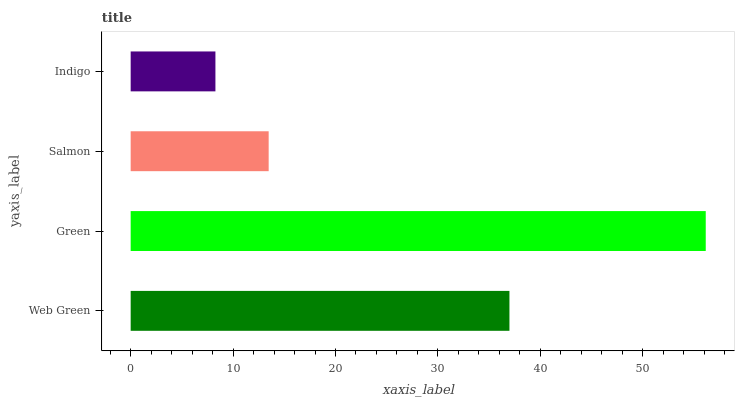Is Indigo the minimum?
Answer yes or no. Yes. Is Green the maximum?
Answer yes or no. Yes. Is Salmon the minimum?
Answer yes or no. No. Is Salmon the maximum?
Answer yes or no. No. Is Green greater than Salmon?
Answer yes or no. Yes. Is Salmon less than Green?
Answer yes or no. Yes. Is Salmon greater than Green?
Answer yes or no. No. Is Green less than Salmon?
Answer yes or no. No. Is Web Green the high median?
Answer yes or no. Yes. Is Salmon the low median?
Answer yes or no. Yes. Is Indigo the high median?
Answer yes or no. No. Is Indigo the low median?
Answer yes or no. No. 